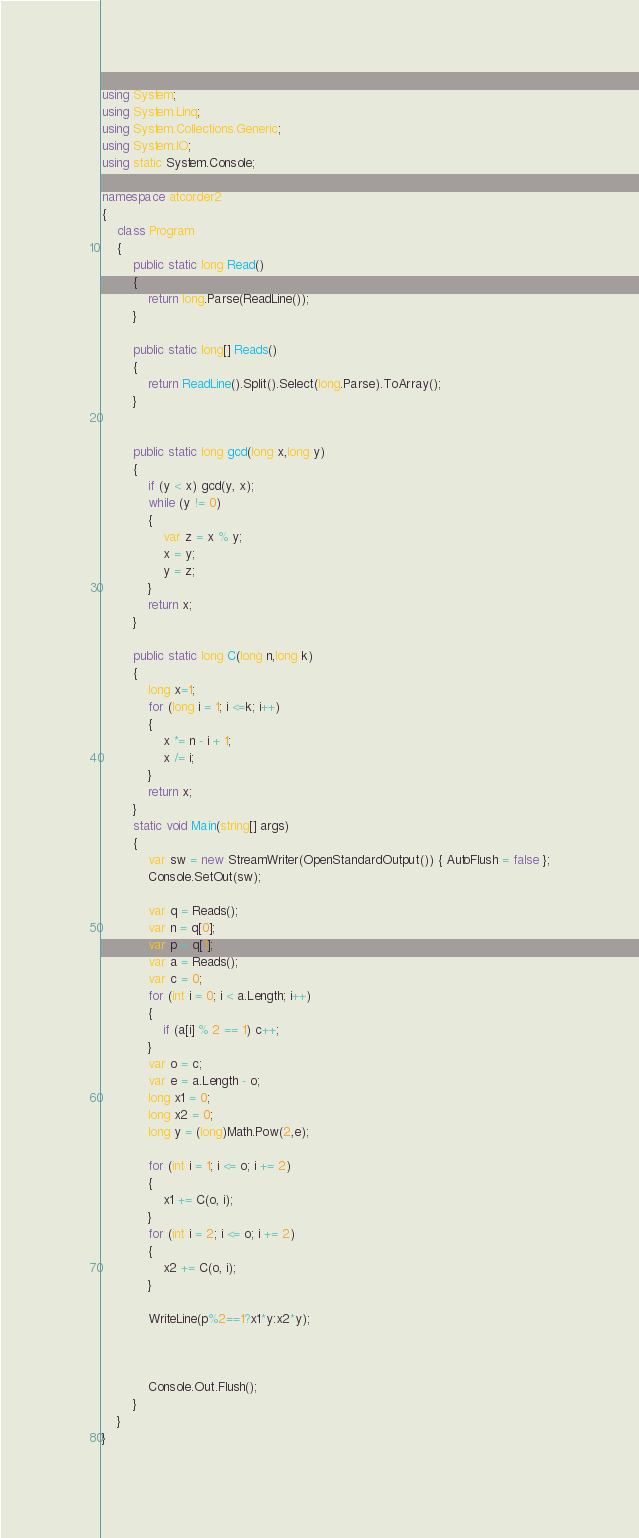<code> <loc_0><loc_0><loc_500><loc_500><_C#_>using System;
using System.Linq;
using System.Collections.Generic;
using System.IO;
using static System.Console;

namespace atcorder2
{
    class Program
    {
        public static long Read()
        {
            return long.Parse(ReadLine());
        }

        public static long[] Reads()
        {
            return ReadLine().Split().Select(long.Parse).ToArray();
        }


        public static long gcd(long x,long y)
        {
            if (y < x) gcd(y, x);
            while (y != 0)
            {
                var z = x % y;
                x = y;
                y = z;
            }
            return x;
        }

        public static long C(long n,long k)
        {
            long x=1;
            for (long i = 1; i <=k; i++)
            {
                x *= n - i + 1;
                x /= i;
            }
            return x;
        }
        static void Main(string[] args)
        {
            var sw = new StreamWriter(OpenStandardOutput()) { AutoFlush = false };
            Console.SetOut(sw);

            var q = Reads();
            var n = q[0];
            var p = q[1];
            var a = Reads();
            var c = 0;
            for (int i = 0; i < a.Length; i++)
            {
                if (a[i] % 2 == 1) c++;
            }
            var o = c;
            var e = a.Length - o;
            long x1 = 0;
            long x2 = 0;
            long y = (long)Math.Pow(2,e);
            
            for (int i = 1; i <= o; i += 2)
            {
                x1 += C(o, i);
            }
            for (int i = 2; i <= o; i += 2)
            {
                x2 += C(o, i);
            }

            WriteLine(p%2==1?x1*y:x2*y);
            


            Console.Out.Flush();
        }
    }
}
</code> 